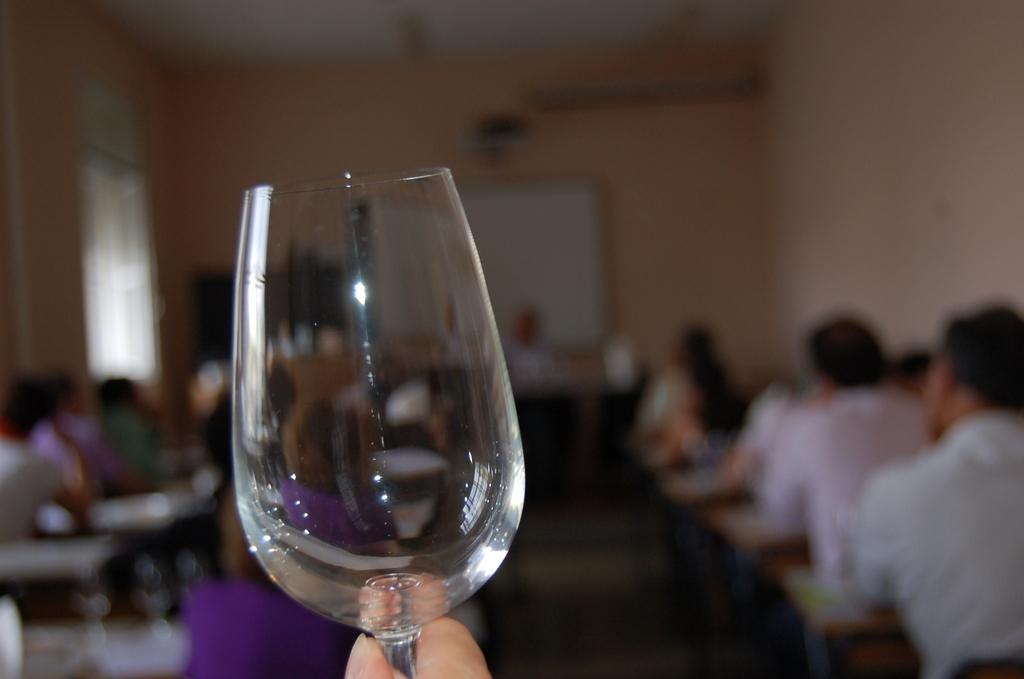Where was the image taken? The image was taken in a room. How many people are in the image? There are multiple persons in the image. What is the person in the front holding? The person in the front is holding a wine glass. What can be seen on the wall in the background? There is a board on the wall in the background. What type of advice is written on the scarf in the image? There is no scarf present in the image, and therefore no advice can be read from it. How many dimes are visible on the board in the background? There are no dimes visible on the board in the background; only a board can be seen. 